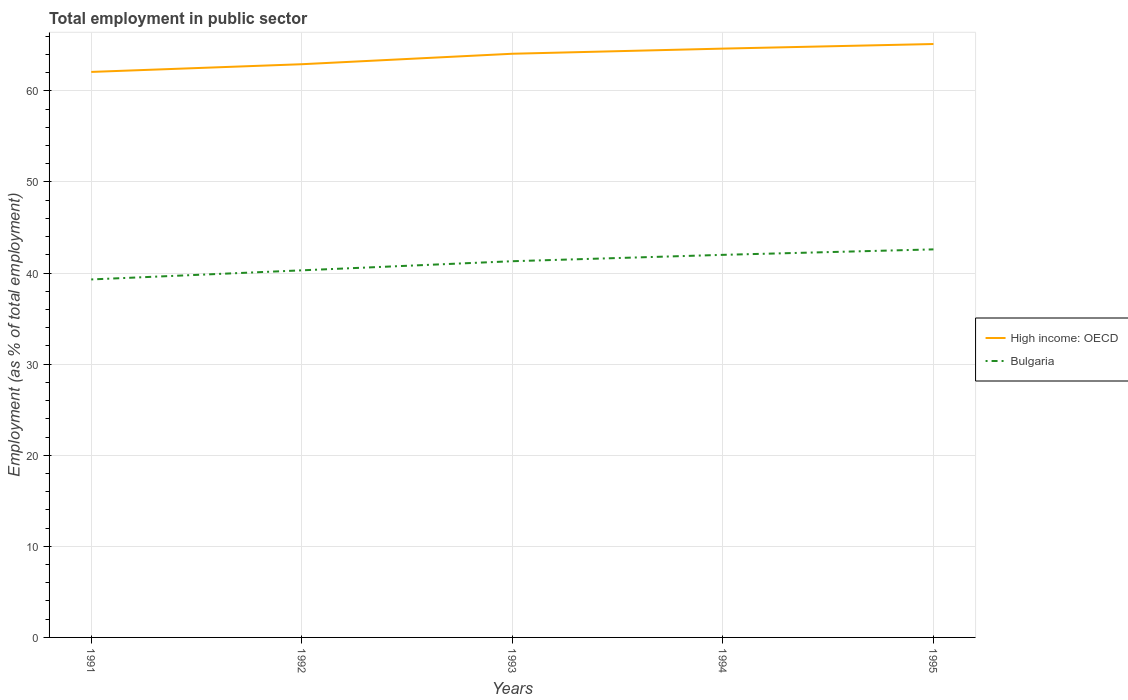How many different coloured lines are there?
Give a very brief answer. 2. Does the line corresponding to High income: OECD intersect with the line corresponding to Bulgaria?
Offer a terse response. No. Across all years, what is the maximum employment in public sector in Bulgaria?
Keep it short and to the point. 39.3. In which year was the employment in public sector in High income: OECD maximum?
Your answer should be very brief. 1991. What is the total employment in public sector in Bulgaria in the graph?
Keep it short and to the point. -1. What is the difference between the highest and the second highest employment in public sector in High income: OECD?
Provide a short and direct response. 3.06. What is the difference between the highest and the lowest employment in public sector in High income: OECD?
Your response must be concise. 3. How many years are there in the graph?
Your answer should be compact. 5. What is the difference between two consecutive major ticks on the Y-axis?
Your answer should be very brief. 10. Does the graph contain grids?
Give a very brief answer. Yes. Where does the legend appear in the graph?
Your answer should be compact. Center right. What is the title of the graph?
Offer a very short reply. Total employment in public sector. Does "Heavily indebted poor countries" appear as one of the legend labels in the graph?
Your answer should be compact. No. What is the label or title of the X-axis?
Give a very brief answer. Years. What is the label or title of the Y-axis?
Your response must be concise. Employment (as % of total employment). What is the Employment (as % of total employment) in High income: OECD in 1991?
Your response must be concise. 62.08. What is the Employment (as % of total employment) in Bulgaria in 1991?
Offer a terse response. 39.3. What is the Employment (as % of total employment) of High income: OECD in 1992?
Your answer should be compact. 62.93. What is the Employment (as % of total employment) of Bulgaria in 1992?
Make the answer very short. 40.3. What is the Employment (as % of total employment) of High income: OECD in 1993?
Ensure brevity in your answer.  64.08. What is the Employment (as % of total employment) of Bulgaria in 1993?
Offer a very short reply. 41.3. What is the Employment (as % of total employment) of High income: OECD in 1994?
Your answer should be very brief. 64.64. What is the Employment (as % of total employment) in High income: OECD in 1995?
Ensure brevity in your answer.  65.14. What is the Employment (as % of total employment) of Bulgaria in 1995?
Make the answer very short. 42.6. Across all years, what is the maximum Employment (as % of total employment) in High income: OECD?
Provide a succinct answer. 65.14. Across all years, what is the maximum Employment (as % of total employment) of Bulgaria?
Your answer should be compact. 42.6. Across all years, what is the minimum Employment (as % of total employment) in High income: OECD?
Provide a succinct answer. 62.08. Across all years, what is the minimum Employment (as % of total employment) of Bulgaria?
Your response must be concise. 39.3. What is the total Employment (as % of total employment) in High income: OECD in the graph?
Your response must be concise. 318.87. What is the total Employment (as % of total employment) in Bulgaria in the graph?
Your answer should be compact. 205.5. What is the difference between the Employment (as % of total employment) of High income: OECD in 1991 and that in 1992?
Keep it short and to the point. -0.85. What is the difference between the Employment (as % of total employment) of High income: OECD in 1991 and that in 1993?
Provide a succinct answer. -2. What is the difference between the Employment (as % of total employment) of Bulgaria in 1991 and that in 1993?
Offer a very short reply. -2. What is the difference between the Employment (as % of total employment) in High income: OECD in 1991 and that in 1994?
Ensure brevity in your answer.  -2.56. What is the difference between the Employment (as % of total employment) in High income: OECD in 1991 and that in 1995?
Your answer should be compact. -3.06. What is the difference between the Employment (as % of total employment) of High income: OECD in 1992 and that in 1993?
Make the answer very short. -1.15. What is the difference between the Employment (as % of total employment) of Bulgaria in 1992 and that in 1993?
Keep it short and to the point. -1. What is the difference between the Employment (as % of total employment) of High income: OECD in 1992 and that in 1994?
Your answer should be compact. -1.71. What is the difference between the Employment (as % of total employment) of Bulgaria in 1992 and that in 1994?
Keep it short and to the point. -1.7. What is the difference between the Employment (as % of total employment) of High income: OECD in 1992 and that in 1995?
Ensure brevity in your answer.  -2.22. What is the difference between the Employment (as % of total employment) in High income: OECD in 1993 and that in 1994?
Give a very brief answer. -0.56. What is the difference between the Employment (as % of total employment) of High income: OECD in 1993 and that in 1995?
Ensure brevity in your answer.  -1.07. What is the difference between the Employment (as % of total employment) of Bulgaria in 1993 and that in 1995?
Offer a very short reply. -1.3. What is the difference between the Employment (as % of total employment) of High income: OECD in 1994 and that in 1995?
Make the answer very short. -0.5. What is the difference between the Employment (as % of total employment) in High income: OECD in 1991 and the Employment (as % of total employment) in Bulgaria in 1992?
Your answer should be compact. 21.78. What is the difference between the Employment (as % of total employment) in High income: OECD in 1991 and the Employment (as % of total employment) in Bulgaria in 1993?
Make the answer very short. 20.78. What is the difference between the Employment (as % of total employment) of High income: OECD in 1991 and the Employment (as % of total employment) of Bulgaria in 1994?
Your answer should be compact. 20.08. What is the difference between the Employment (as % of total employment) in High income: OECD in 1991 and the Employment (as % of total employment) in Bulgaria in 1995?
Offer a very short reply. 19.48. What is the difference between the Employment (as % of total employment) in High income: OECD in 1992 and the Employment (as % of total employment) in Bulgaria in 1993?
Your answer should be very brief. 21.63. What is the difference between the Employment (as % of total employment) in High income: OECD in 1992 and the Employment (as % of total employment) in Bulgaria in 1994?
Provide a succinct answer. 20.93. What is the difference between the Employment (as % of total employment) of High income: OECD in 1992 and the Employment (as % of total employment) of Bulgaria in 1995?
Make the answer very short. 20.33. What is the difference between the Employment (as % of total employment) in High income: OECD in 1993 and the Employment (as % of total employment) in Bulgaria in 1994?
Your response must be concise. 22.08. What is the difference between the Employment (as % of total employment) of High income: OECD in 1993 and the Employment (as % of total employment) of Bulgaria in 1995?
Your response must be concise. 21.48. What is the difference between the Employment (as % of total employment) of High income: OECD in 1994 and the Employment (as % of total employment) of Bulgaria in 1995?
Keep it short and to the point. 22.04. What is the average Employment (as % of total employment) of High income: OECD per year?
Provide a short and direct response. 63.77. What is the average Employment (as % of total employment) of Bulgaria per year?
Provide a succinct answer. 41.1. In the year 1991, what is the difference between the Employment (as % of total employment) of High income: OECD and Employment (as % of total employment) of Bulgaria?
Provide a short and direct response. 22.78. In the year 1992, what is the difference between the Employment (as % of total employment) of High income: OECD and Employment (as % of total employment) of Bulgaria?
Your answer should be compact. 22.63. In the year 1993, what is the difference between the Employment (as % of total employment) in High income: OECD and Employment (as % of total employment) in Bulgaria?
Offer a terse response. 22.78. In the year 1994, what is the difference between the Employment (as % of total employment) of High income: OECD and Employment (as % of total employment) of Bulgaria?
Your answer should be compact. 22.64. In the year 1995, what is the difference between the Employment (as % of total employment) of High income: OECD and Employment (as % of total employment) of Bulgaria?
Your answer should be very brief. 22.54. What is the ratio of the Employment (as % of total employment) of High income: OECD in 1991 to that in 1992?
Your answer should be very brief. 0.99. What is the ratio of the Employment (as % of total employment) of Bulgaria in 1991 to that in 1992?
Keep it short and to the point. 0.98. What is the ratio of the Employment (as % of total employment) in High income: OECD in 1991 to that in 1993?
Offer a very short reply. 0.97. What is the ratio of the Employment (as % of total employment) in Bulgaria in 1991 to that in 1993?
Offer a terse response. 0.95. What is the ratio of the Employment (as % of total employment) of High income: OECD in 1991 to that in 1994?
Your response must be concise. 0.96. What is the ratio of the Employment (as % of total employment) in Bulgaria in 1991 to that in 1994?
Your answer should be very brief. 0.94. What is the ratio of the Employment (as % of total employment) of High income: OECD in 1991 to that in 1995?
Your response must be concise. 0.95. What is the ratio of the Employment (as % of total employment) of Bulgaria in 1991 to that in 1995?
Keep it short and to the point. 0.92. What is the ratio of the Employment (as % of total employment) of High income: OECD in 1992 to that in 1993?
Offer a very short reply. 0.98. What is the ratio of the Employment (as % of total employment) of Bulgaria in 1992 to that in 1993?
Your answer should be compact. 0.98. What is the ratio of the Employment (as % of total employment) in High income: OECD in 1992 to that in 1994?
Ensure brevity in your answer.  0.97. What is the ratio of the Employment (as % of total employment) of Bulgaria in 1992 to that in 1994?
Provide a short and direct response. 0.96. What is the ratio of the Employment (as % of total employment) in Bulgaria in 1992 to that in 1995?
Ensure brevity in your answer.  0.95. What is the ratio of the Employment (as % of total employment) in Bulgaria in 1993 to that in 1994?
Your response must be concise. 0.98. What is the ratio of the Employment (as % of total employment) of High income: OECD in 1993 to that in 1995?
Make the answer very short. 0.98. What is the ratio of the Employment (as % of total employment) in Bulgaria in 1993 to that in 1995?
Provide a succinct answer. 0.97. What is the ratio of the Employment (as % of total employment) of High income: OECD in 1994 to that in 1995?
Your response must be concise. 0.99. What is the ratio of the Employment (as % of total employment) in Bulgaria in 1994 to that in 1995?
Your response must be concise. 0.99. What is the difference between the highest and the second highest Employment (as % of total employment) in High income: OECD?
Ensure brevity in your answer.  0.5. What is the difference between the highest and the second highest Employment (as % of total employment) in Bulgaria?
Give a very brief answer. 0.6. What is the difference between the highest and the lowest Employment (as % of total employment) of High income: OECD?
Your answer should be very brief. 3.06. 